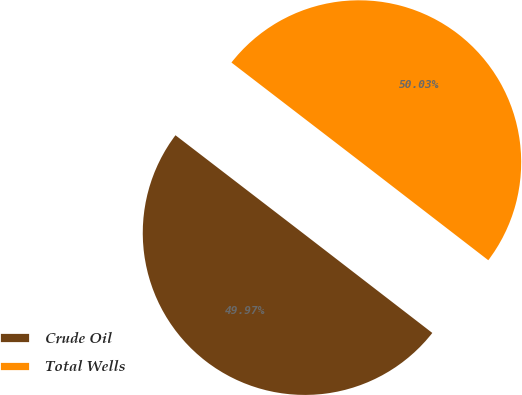Convert chart. <chart><loc_0><loc_0><loc_500><loc_500><pie_chart><fcel>Crude Oil<fcel>Total Wells<nl><fcel>49.97%<fcel>50.03%<nl></chart> 